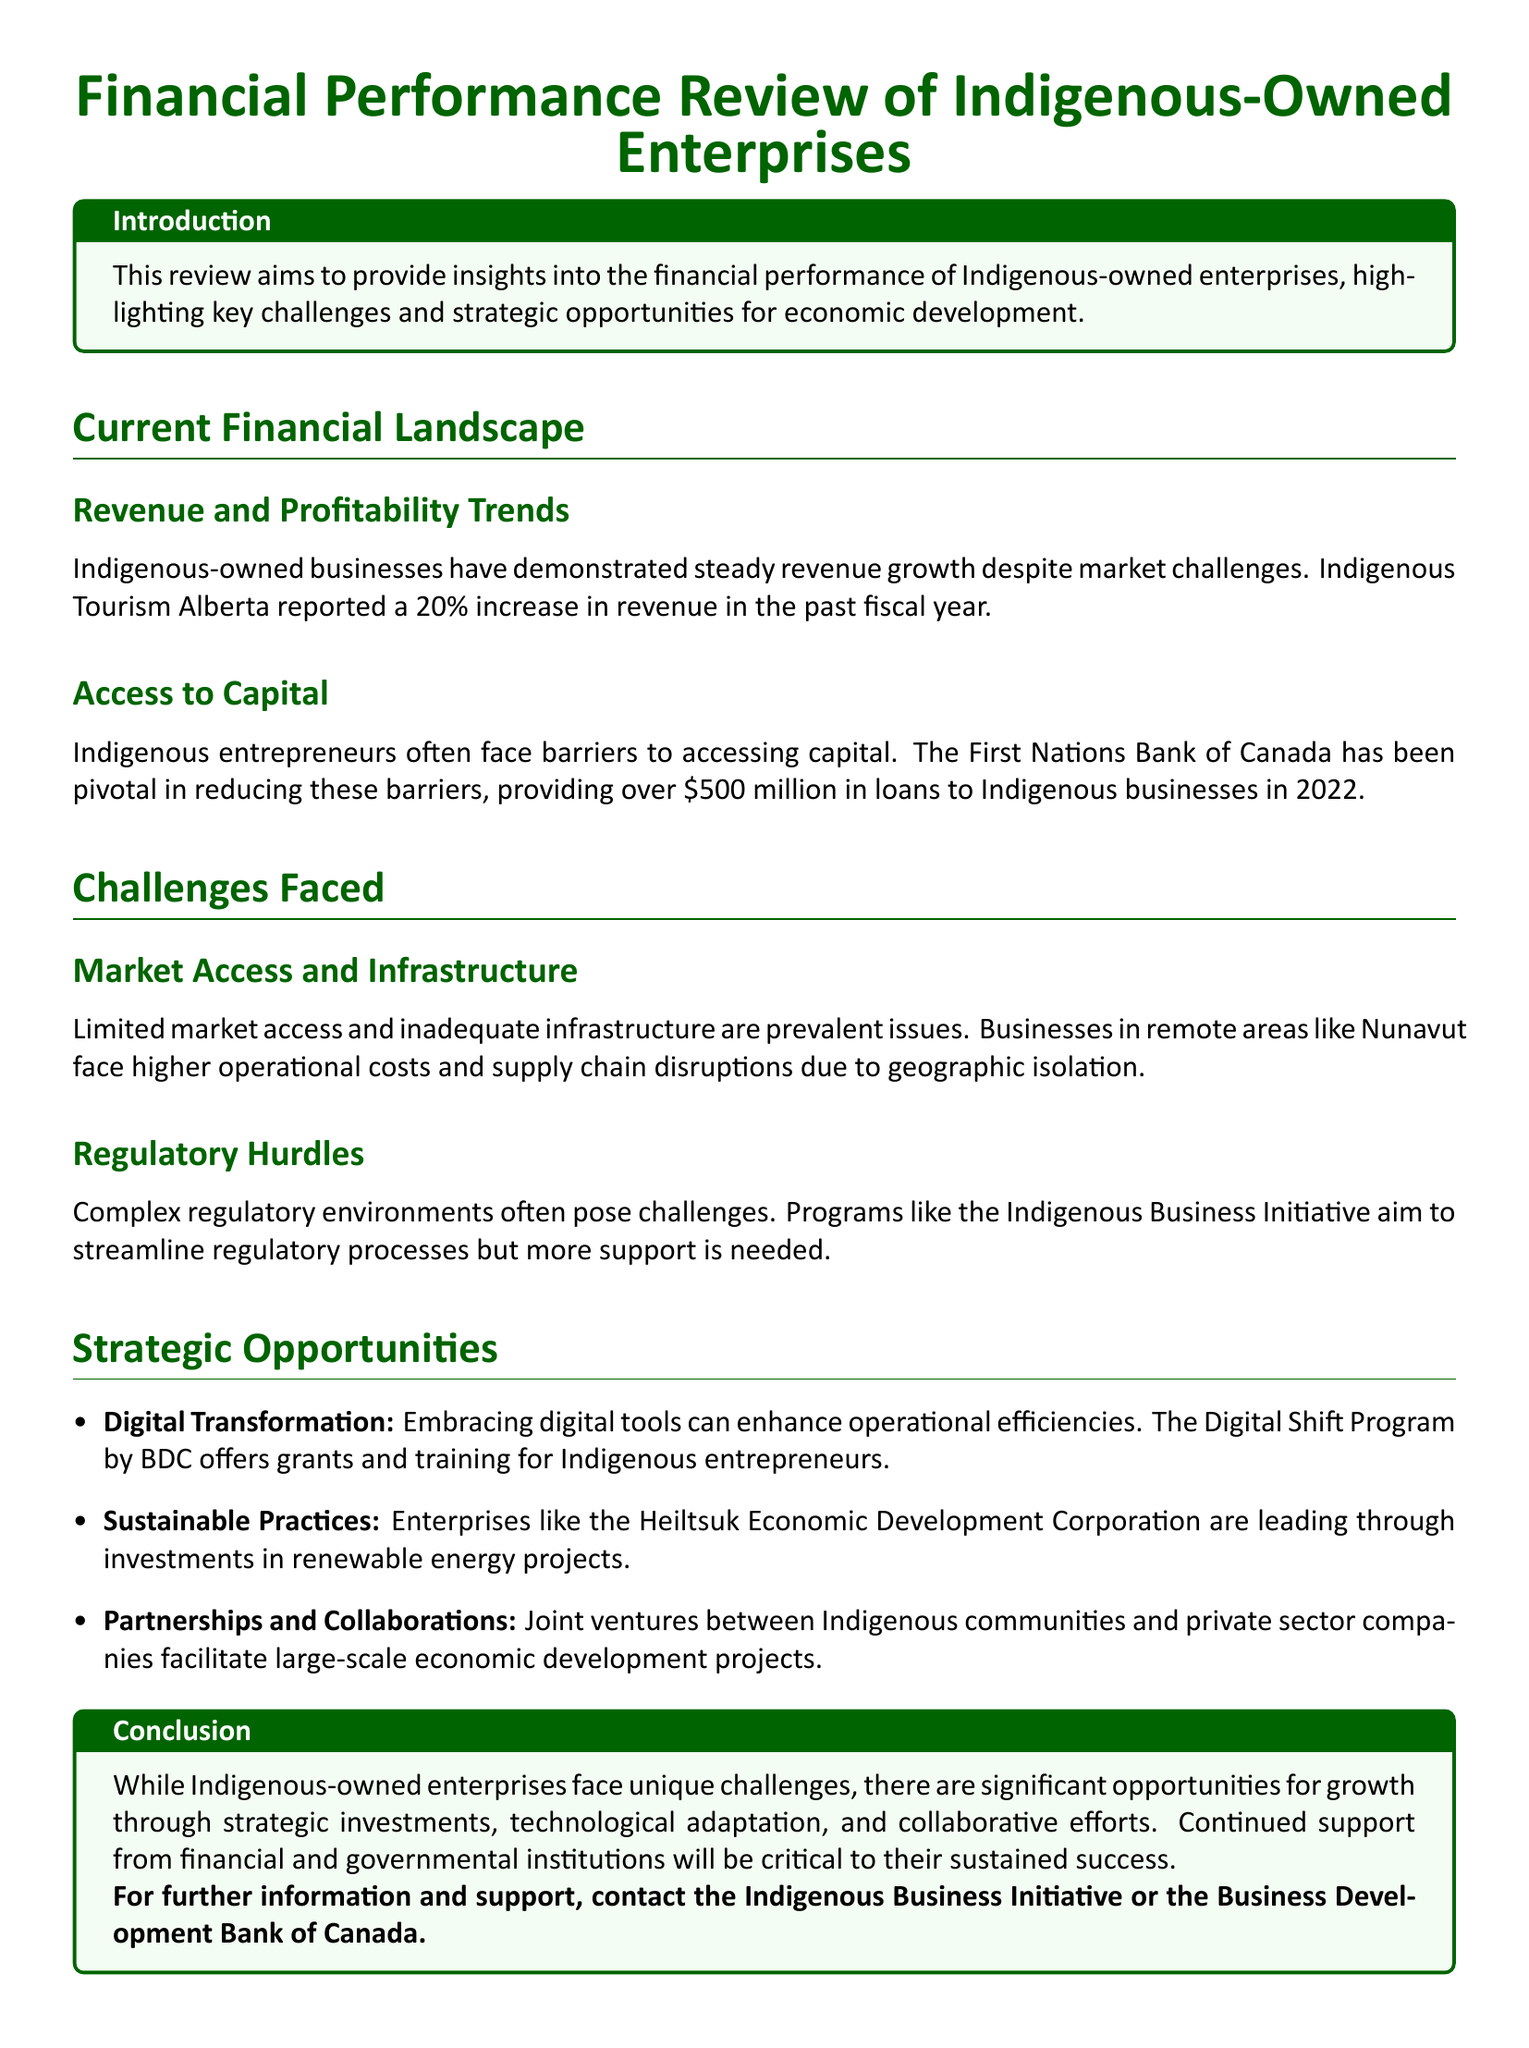What was the revenue increase percentage reported by Indigenous Tourism Alberta? The document states that Indigenous Tourism Alberta reported a 20% increase in revenue in the past fiscal year.
Answer: 20% How much did the First Nations Bank of Canada provide in loans to Indigenous businesses in 2022? The document mentions that the First Nations Bank of Canada provided over $500 million in loans to Indigenous businesses in 2022.
Answer: over $500 million What are the main issues faced by businesses in remote areas like Nunavut according to the document? The document highlights limited market access and inadequate infrastructure as prevalent issues in remote areas like Nunavut.
Answer: Limited market access and inadequate infrastructure What program is mentioned in the document to assist with regulatory processes? The Indigenous Business Initiative is mentioned as a program that aims to streamline regulatory processes.
Answer: Indigenous Business Initiative Which organization facilitates grants and training for digital transformation for Indigenous entrepreneurs? The document refers to the Digital Shift Program by BDC as facilitating grants and training for Indigenous entrepreneurs.
Answer: Digital Shift Program by BDC What type of practices are highlighted as a strategic opportunity in the document? The document mentions sustainable practices as a strategic opportunity for Indigenous-owned enterprises.
Answer: Sustainable practices What is emphasized as critical for the sustained success of Indigenous-owned enterprises? The document emphasizes that continued support from financial and governmental institutions will be critical for the sustained success of Indigenous-owned enterprises.
Answer: Continued support from financial and governmental institutions 